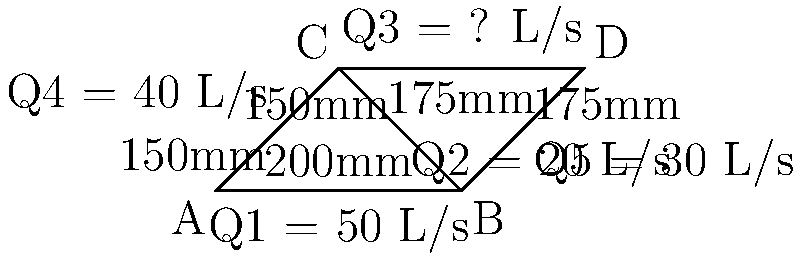In this pipe network, water flows from points A and B to points C and D. Given the flow rates and pipe diameters shown in the diagram, determine the flow rate Q3 in the pipe connecting points C and D. How does this relate to the loading time of web pages? To solve this problem, we'll use the principle of conservation of mass, which states that the total inflow must equal the total outflow at each junction. We'll approach this step-by-step:

1. Identify the known flow rates:
   Q1 = 50 L/s (inflow)
   Q2 = 20 L/s (from B to C)
   Q4 = 40 L/s (from A to C)
   Q5 = 30 L/s (from B to D)

2. Apply conservation of mass at junction B:
   Inflow at B = Outflow from B
   Q1 = Q2 + Q5
   50 = 20 + 30 (This checks out)

3. Apply conservation of mass at junction C:
   Inflow at C = Outflow from C
   Q2 + Q4 = Q3
   20 + 40 = Q3
   Q3 = 60 L/s

4. Verify conservation of mass at junction D:
   Inflow at D = Outflow from D
   Q3 + Q5 = 60 + 30 = 90 L/s (This should equal the total inflow Q1 = 50 L/s)

Therefore, the flow rate Q3 in the pipe connecting points C and D is 60 L/s.

Relating this to web page loading times:
Just as water flow in pipes is affected by pipe diameter and flow rates, data transfer in networks is influenced by bandwidth and data volume. Larger pipe diameters allow for higher flow rates, similar to how higher bandwidth allows for faster data transfer. Efficient network design, like optimized pipe networks, can lead to faster loading times for web pages, which is crucial for a fashion blogger browsing online stores.
Answer: 60 L/s 